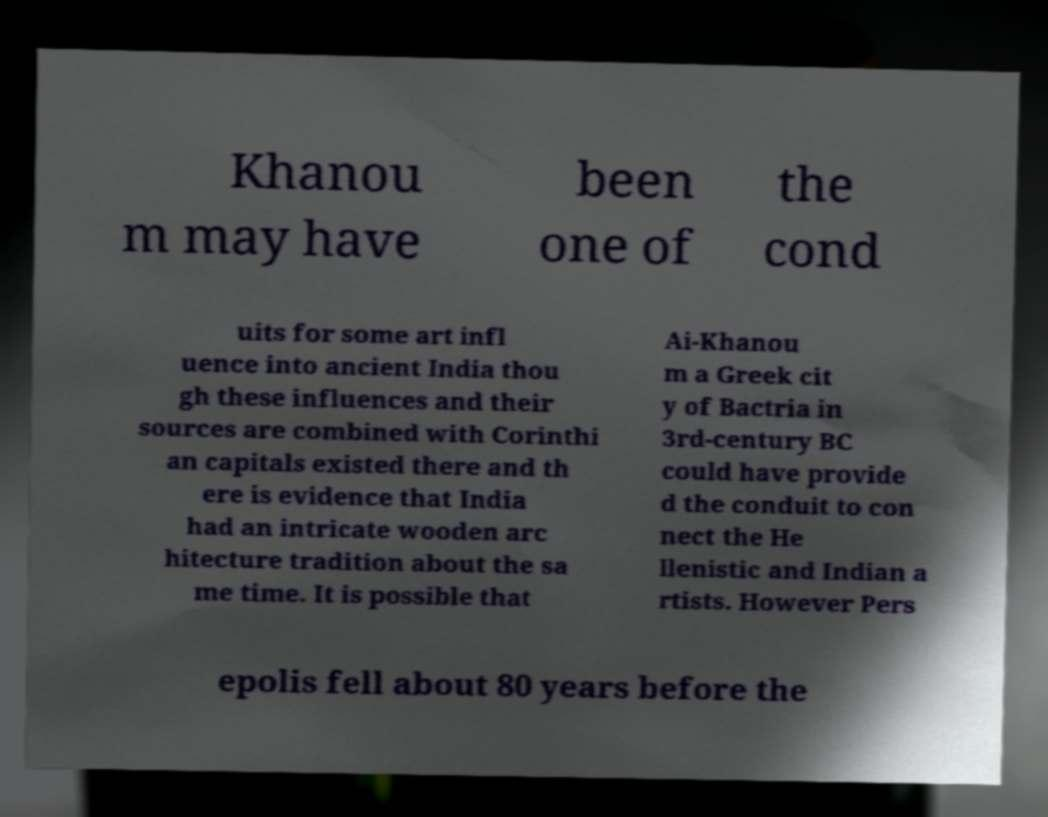Could you assist in decoding the text presented in this image and type it out clearly? Khanou m may have been one of the cond uits for some art infl uence into ancient India thou gh these influences and their sources are combined with Corinthi an capitals existed there and th ere is evidence that India had an intricate wooden arc hitecture tradition about the sa me time. It is possible that Ai-Khanou m a Greek cit y of Bactria in 3rd-century BC could have provide d the conduit to con nect the He llenistic and Indian a rtists. However Pers epolis fell about 80 years before the 